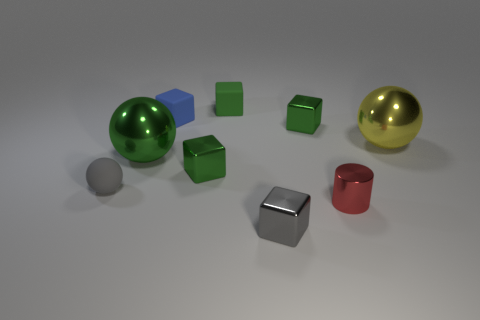Subtract all green blocks. How many were subtracted if there are1green blocks left? 2 Subtract all red balls. How many green blocks are left? 3 Subtract 1 cubes. How many cubes are left? 4 Subtract all blue cubes. How many cubes are left? 4 Subtract all gray shiny cubes. How many cubes are left? 4 Subtract all yellow blocks. Subtract all purple spheres. How many blocks are left? 5 Add 1 tiny blue matte cubes. How many objects exist? 10 Subtract all balls. How many objects are left? 6 Add 4 red metallic things. How many red metallic things are left? 5 Add 2 small green shiny blocks. How many small green shiny blocks exist? 4 